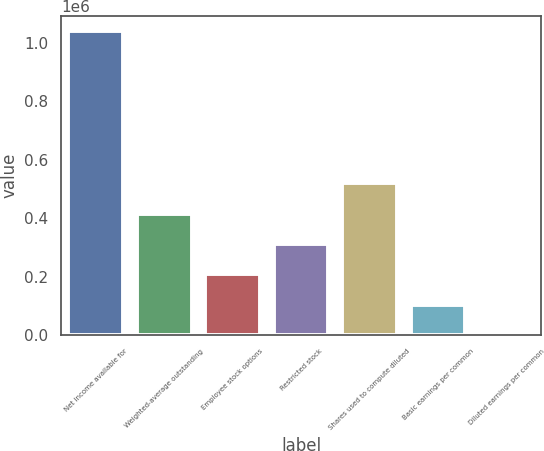<chart> <loc_0><loc_0><loc_500><loc_500><bar_chart><fcel>Net income available for<fcel>Weighted-average outstanding<fcel>Employee stock options<fcel>Restricted stock<fcel>Shares used to compute diluted<fcel>Basic earnings per common<fcel>Diluted earnings per common<nl><fcel>1.03968e+06<fcel>415874<fcel>207940<fcel>311907<fcel>519841<fcel>103973<fcel>6.15<nl></chart> 